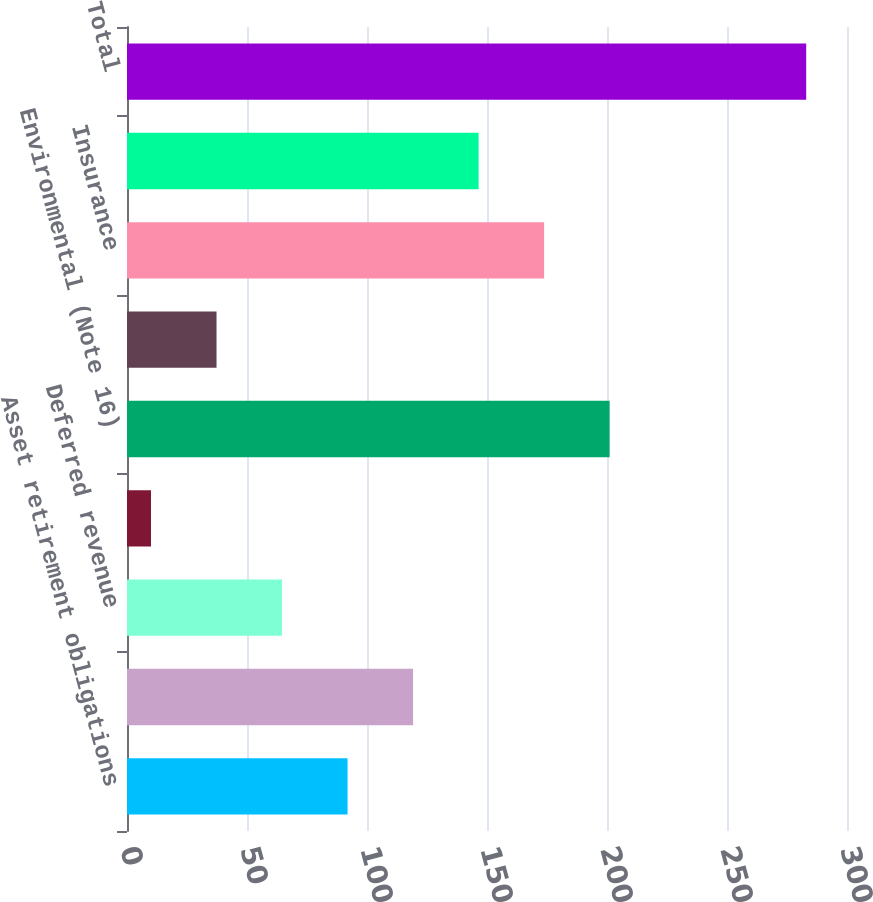Convert chart to OTSL. <chart><loc_0><loc_0><loc_500><loc_500><bar_chart><fcel>Asset retirement obligations<fcel>Deferred proceeds<fcel>Deferred revenue<fcel>Derivatives (Note 22)<fcel>Environmental (Note 16)<fcel>Income taxes payable<fcel>Insurance<fcel>Other<fcel>Total<nl><fcel>91.9<fcel>119.2<fcel>64.6<fcel>10<fcel>201.1<fcel>37.3<fcel>173.8<fcel>146.5<fcel>283<nl></chart> 